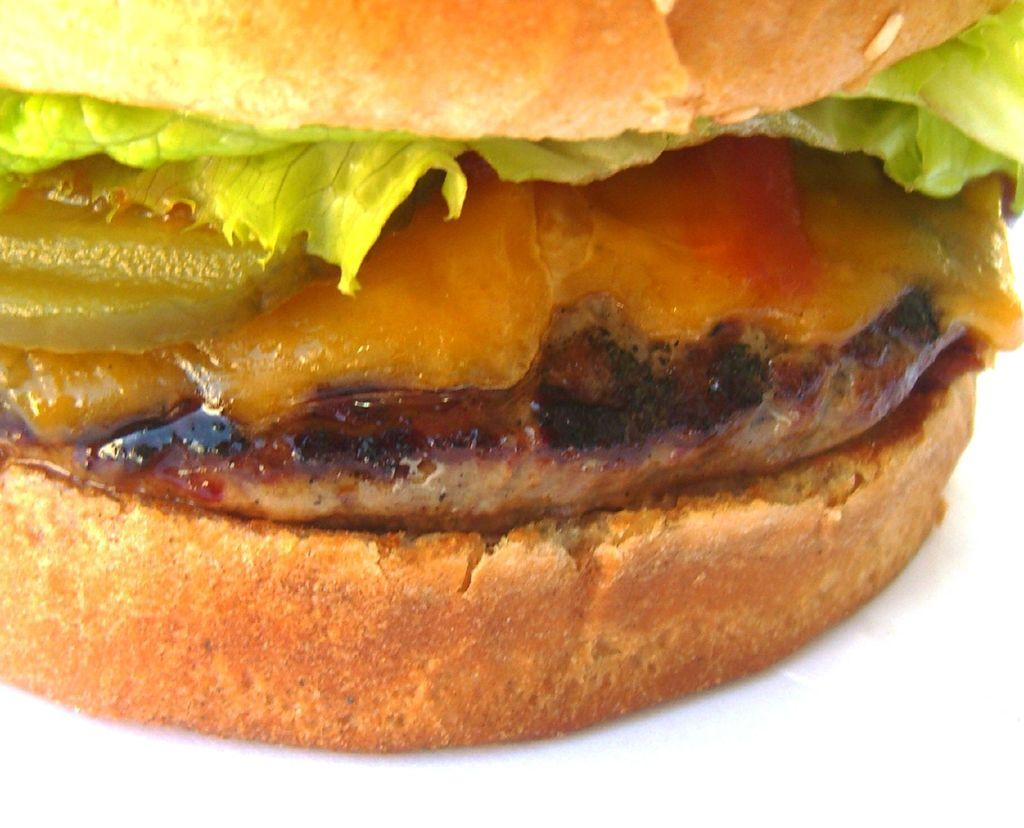What type of food is the main subject of the image? There is a burger in the image. What ingredients can be seen in the burger? The burger contains lettuce, sauce, and meat. What type of shoes is the burger wearing in the image? There are no shoes present in the image, as the main subject is a burger. 